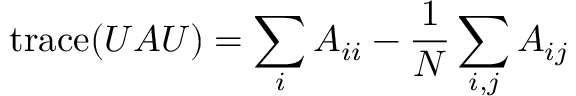<formula> <loc_0><loc_0><loc_500><loc_500>t r a c e ( U A U ) = \sum _ { i } { A _ { i i } } - \frac { 1 } { N } \sum _ { i , j } { A _ { i j } }</formula> 